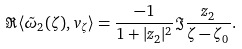Convert formula to latex. <formula><loc_0><loc_0><loc_500><loc_500>\Re \langle \tilde { \omega } _ { 2 } ( \zeta ) , v _ { \zeta } \rangle = \frac { - 1 } { 1 + | z _ { 2 } | ^ { 2 } } \Im \frac { z _ { 2 } } { \zeta - \zeta _ { 0 } } .</formula> 